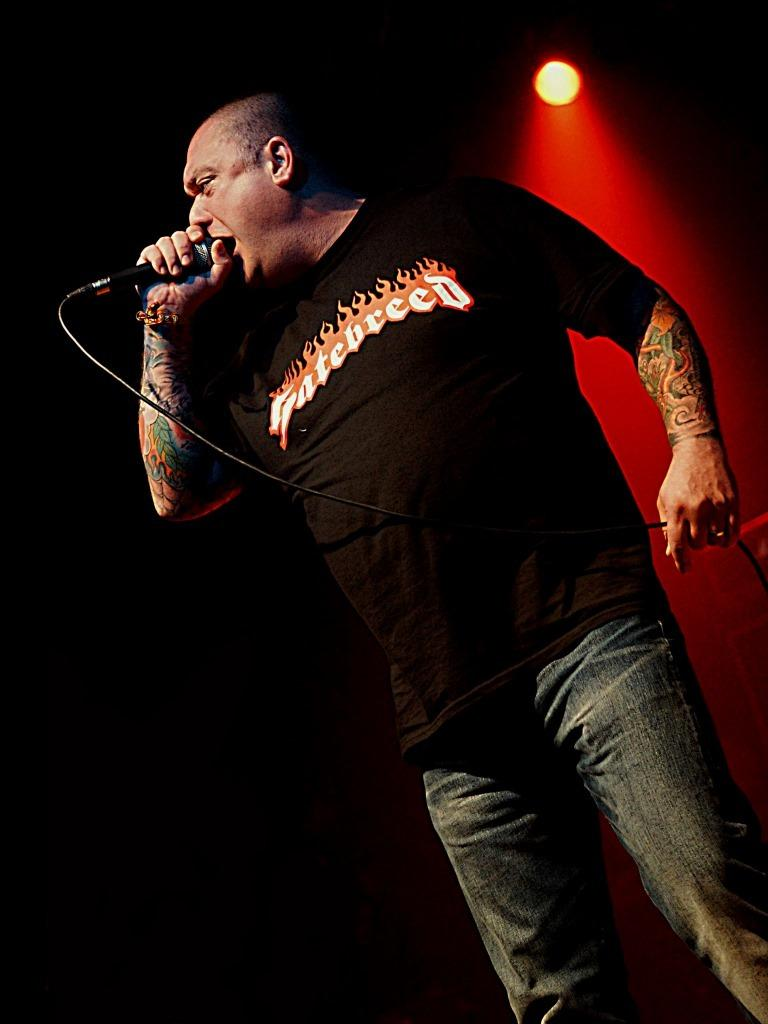Who is the main subject in the image? There is a man in the image. What is the man wearing? The man is wearing a black t-shirt. What is the man doing in the image? The man is standing and singing a song. What object is the man holding in his hand? The man is holding a microphone in his hand. What can be seen in the background of the image? There is a light in the background of the image. Can you see any ghosts interacting with the man in the image? There are no ghosts present in the image. What type of sail is attached to the man's clothing in the image? The man is not wearing any sail in the image; he is wearing a black t-shirt. 